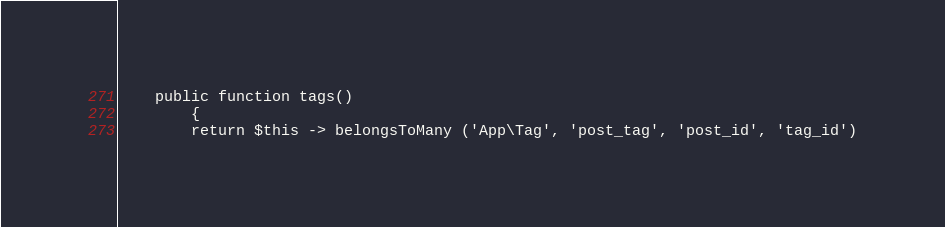Convert code to text. <code><loc_0><loc_0><loc_500><loc_500><_PHP_>
    public function tags()
        {
        return $this -> belongsToMany ('App\Tag', 'post_tag', 'post_id', 'tag_id')</code> 